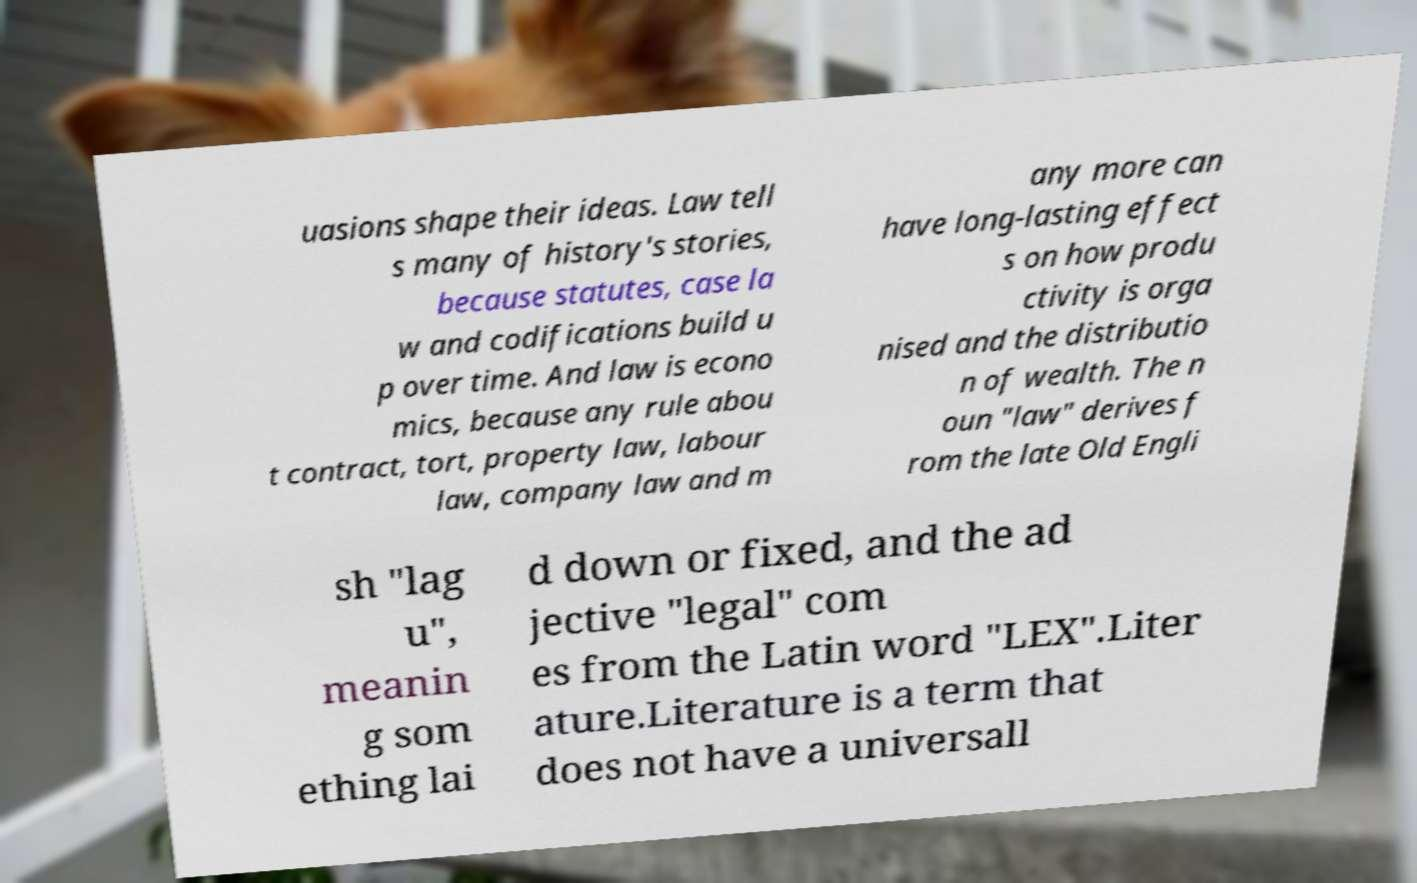There's text embedded in this image that I need extracted. Can you transcribe it verbatim? uasions shape their ideas. Law tell s many of history's stories, because statutes, case la w and codifications build u p over time. And law is econo mics, because any rule abou t contract, tort, property law, labour law, company law and m any more can have long-lasting effect s on how produ ctivity is orga nised and the distributio n of wealth. The n oun "law" derives f rom the late Old Engli sh "lag u", meanin g som ething lai d down or fixed, and the ad jective "legal" com es from the Latin word "LEX".Liter ature.Literature is a term that does not have a universall 